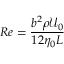Convert formula to latex. <formula><loc_0><loc_0><loc_500><loc_500>R e = \frac { b ^ { 2 } \rho \mathcal { U } _ { 0 } } { 1 2 \eta _ { 0 } L }</formula> 